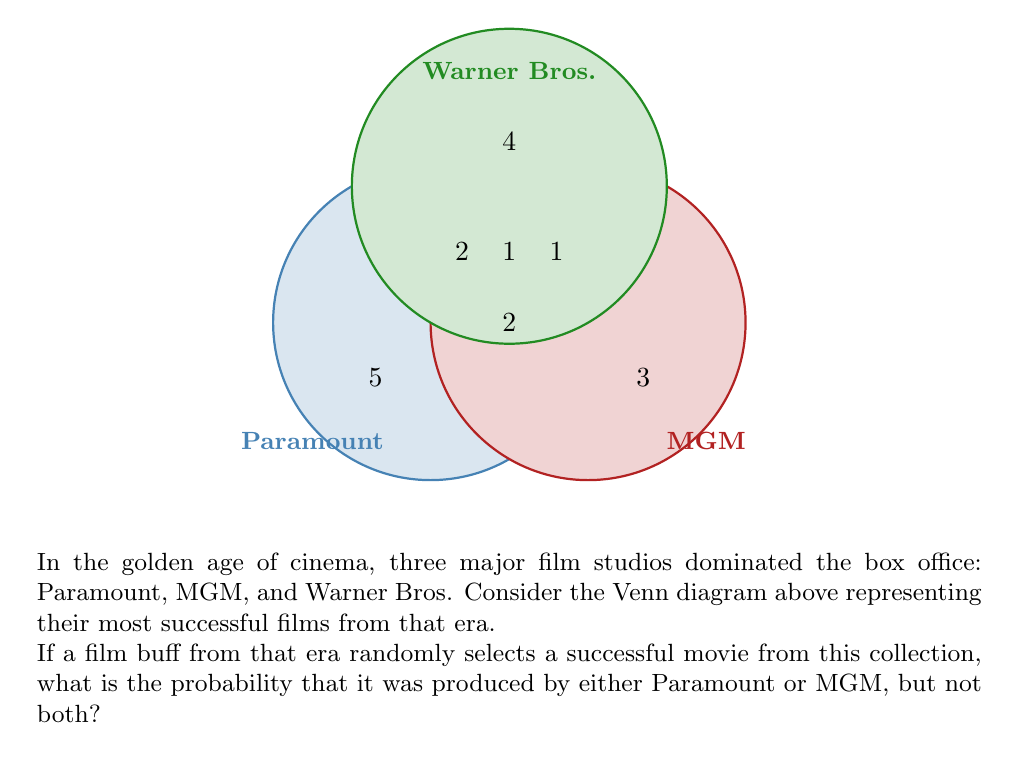Give your solution to this math problem. Let's approach this step-by-step:

1) First, we need to calculate the total number of successful movies in the collection. We can do this by adding up all the numbers in the Venn diagram:

   $5 + 3 + 4 + 2 + 1 + 2 + 1 = 18$ total movies

2) Now, we need to identify the movies that were produced by either Paramount or MGM, but not both. These are:
   - 5 movies produced only by Paramount
   - 3 movies produced only by MGM

3) The total number of movies meeting our criteria is thus:
   $5 + 3 = 8$ movies

4) The probability is calculated by dividing the number of favorable outcomes by the total number of possible outcomes:

   $$P(\text{Paramount or MGM, but not both}) = \frac{\text{Number of movies by Paramount or MGM only}}{\text{Total number of movies}}$$

   $$P(\text{Paramount or MGM, but not both}) = \frac{8}{18}$$

5) This fraction can be reduced:

   $$\frac{8}{18} = \frac{4}{9}$$

Therefore, the probability of randomly selecting a movie produced by either Paramount or MGM, but not both, is $\frac{4}{9}$.
Answer: $\frac{4}{9}$ 